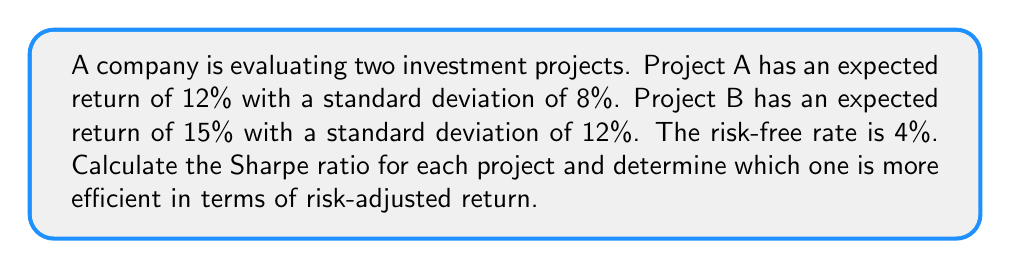Show me your answer to this math problem. To evaluate the efficiency of these projects, we'll use the Sharpe ratio, which measures the excess return per unit of risk. The formula for the Sharpe ratio is:

$$ \text{Sharpe Ratio} = \frac{R_p - R_f}{\sigma_p} $$

Where:
$R_p$ = Expected return of the project
$R_f$ = Risk-free rate
$\sigma_p$ = Standard deviation of the project's returns

Step 1: Calculate the Sharpe ratio for Project A
$$ \text{Sharpe Ratio}_A = \frac{0.12 - 0.04}{0.08} = 1 $$

Step 2: Calculate the Sharpe ratio for Project B
$$ \text{Sharpe Ratio}_B = \frac{0.15 - 0.04}{0.12} = 0.9167 $$

Step 3: Compare the Sharpe ratios

Project A has a higher Sharpe ratio (1) compared to Project B (0.9167). This means that Project A offers a better risk-adjusted return, making it more efficient in terms of the risk-return trade-off.

Although Project B has a higher expected return (15% vs 12%), it also comes with higher risk (12% standard deviation vs 8%). The Sharpe ratio takes both factors into account, showing that the additional return of Project B does not compensate enough for its additional risk.
Answer: Project A (Sharpe ratio: 1) is more efficient than Project B (Sharpe ratio: 0.9167). 